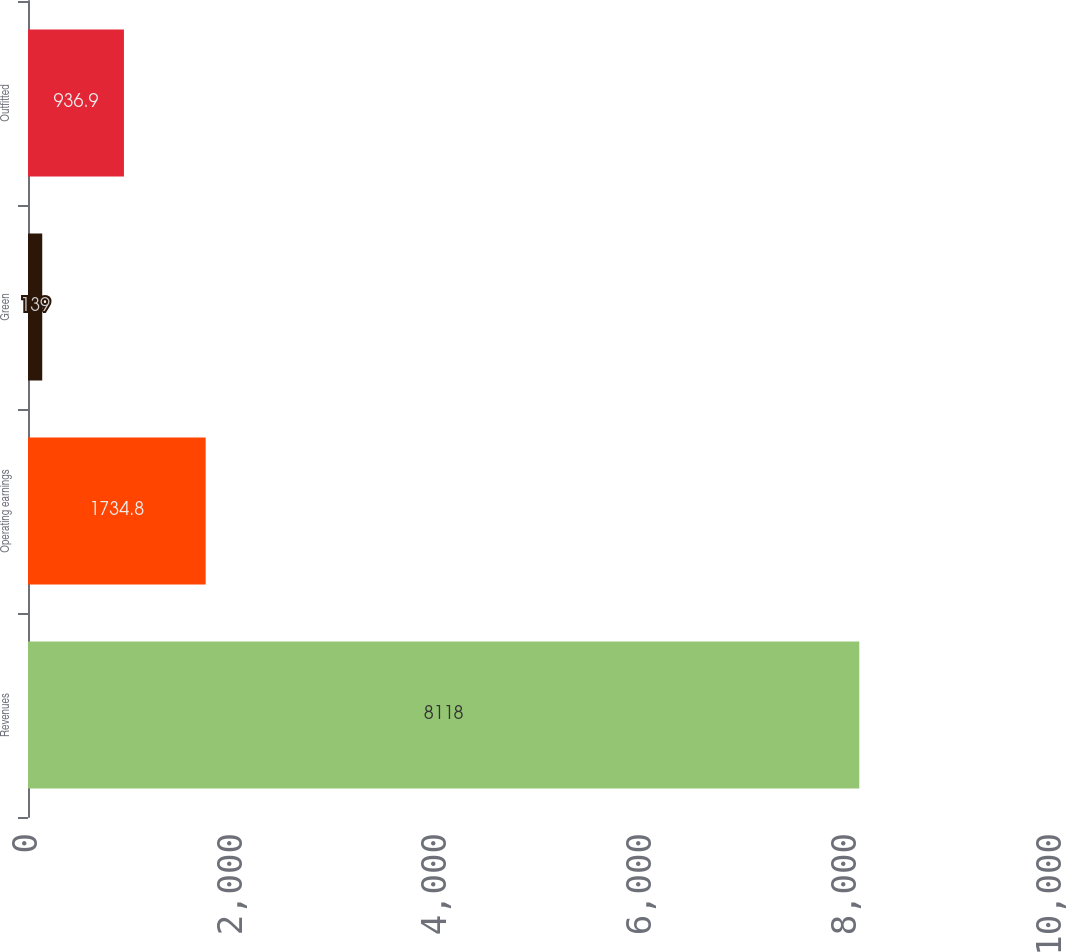Convert chart. <chart><loc_0><loc_0><loc_500><loc_500><bar_chart><fcel>Revenues<fcel>Operating earnings<fcel>Green<fcel>Outfitted<nl><fcel>8118<fcel>1734.8<fcel>139<fcel>936.9<nl></chart> 